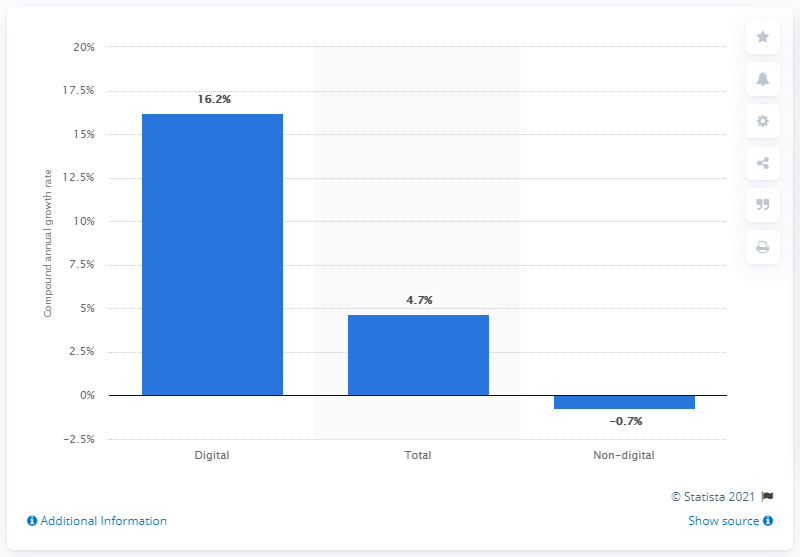Mention a couple of crucial points in this snapshot. The median value bar is represented by the "Total" category. The growth rate of digital advertising is at least 15% higher than the smallest one. 